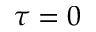<formula> <loc_0><loc_0><loc_500><loc_500>\tau = 0</formula> 